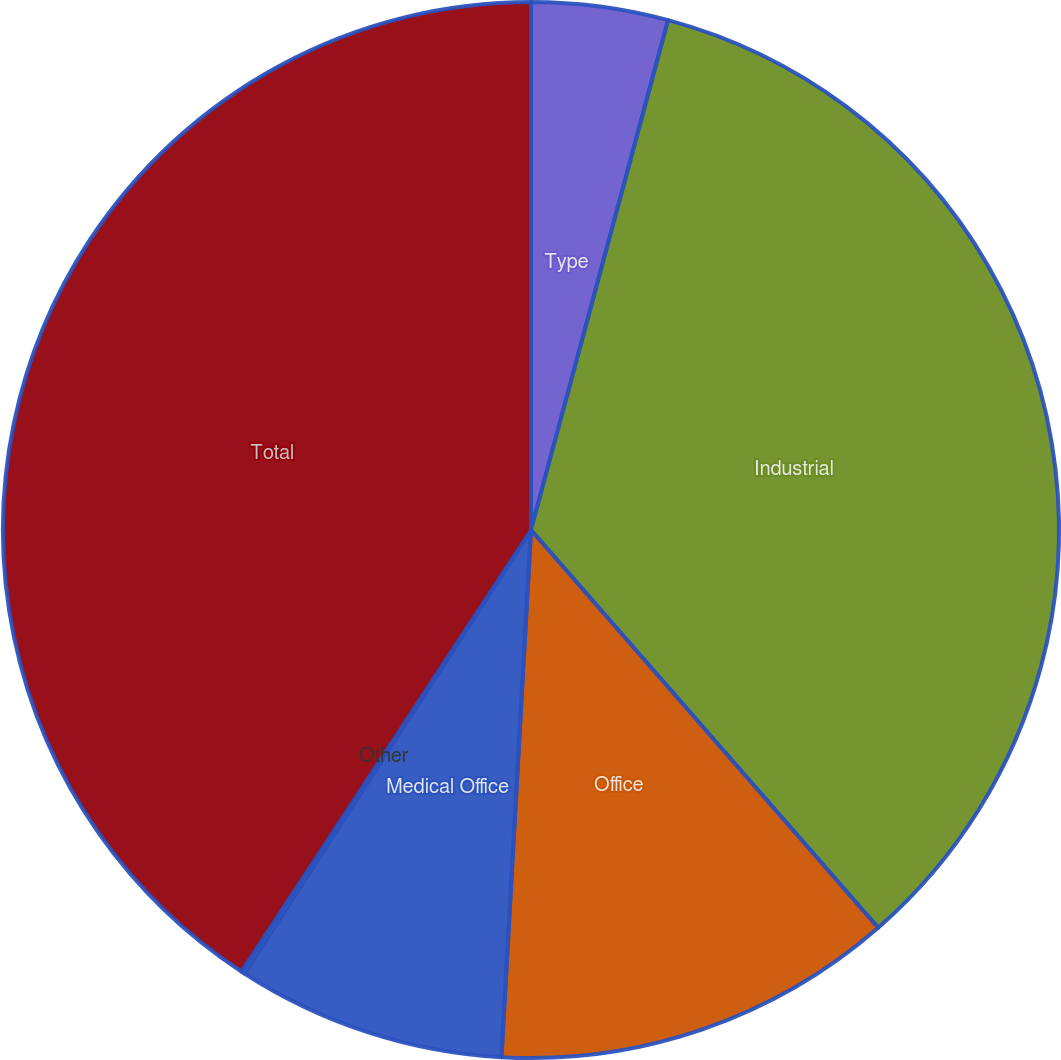Convert chart. <chart><loc_0><loc_0><loc_500><loc_500><pie_chart><fcel>Type<fcel>Industrial<fcel>Office<fcel>Medical Office<fcel>Other<fcel>Total<nl><fcel>4.18%<fcel>34.4%<fcel>12.31%<fcel>8.24%<fcel>0.11%<fcel>40.76%<nl></chart> 